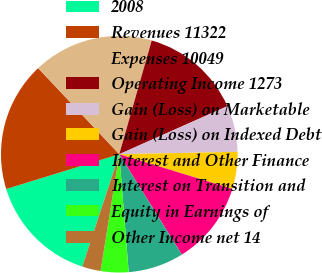<chart> <loc_0><loc_0><loc_500><loc_500><pie_chart><fcel>2008<fcel>Revenues 11322<fcel>Expenses 10049<fcel>Operating Income 1273<fcel>Gain (Loss) on Marketable<fcel>Gain (Loss) on Indexed Debt<fcel>Interest and Other Finance<fcel>Interest on Transition and<fcel>Equity in Earnings of<fcel>Other Income net 14<nl><fcel>15.19%<fcel>17.72%<fcel>16.45%<fcel>13.92%<fcel>6.33%<fcel>5.06%<fcel>11.39%<fcel>7.6%<fcel>3.8%<fcel>2.53%<nl></chart> 